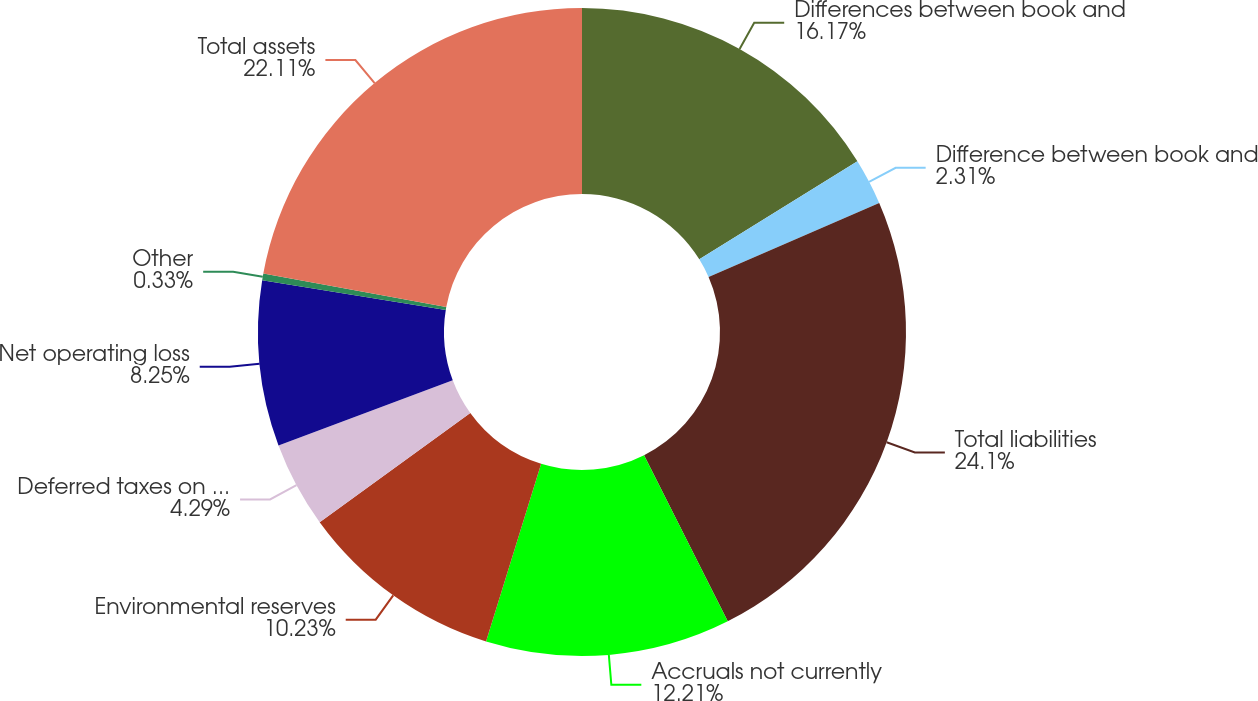<chart> <loc_0><loc_0><loc_500><loc_500><pie_chart><fcel>Differences between book and<fcel>Difference between book and<fcel>Total liabilities<fcel>Accruals not currently<fcel>Environmental reserves<fcel>Deferred taxes on uncertain<fcel>Net operating loss<fcel>Other<fcel>Total assets<nl><fcel>16.17%<fcel>2.31%<fcel>24.09%<fcel>12.21%<fcel>10.23%<fcel>4.29%<fcel>8.25%<fcel>0.33%<fcel>22.11%<nl></chart> 